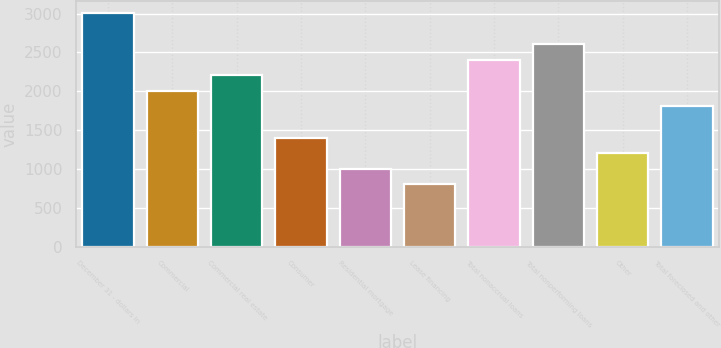Convert chart. <chart><loc_0><loc_0><loc_500><loc_500><bar_chart><fcel>December 31 - dollars in<fcel>Commercial<fcel>Commercial real estate<fcel>Consumer<fcel>Residential mortgage<fcel>Lease financing<fcel>Total nonaccrual loans<fcel>Total nonperforming loans<fcel>Other<fcel>Total foreclosed and other<nl><fcel>3010.36<fcel>2006.96<fcel>2207.64<fcel>1404.92<fcel>1003.56<fcel>802.88<fcel>2408.32<fcel>2609<fcel>1204.24<fcel>1806.28<nl></chart> 